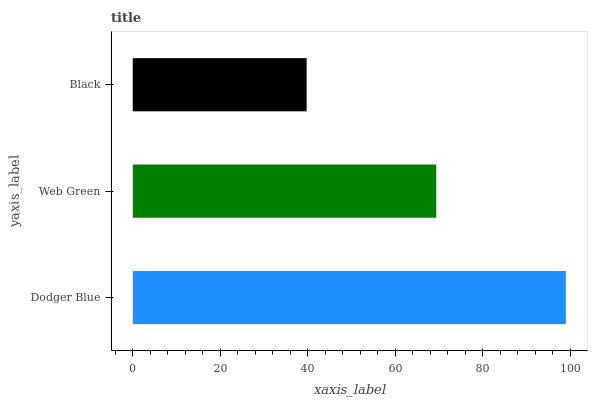Is Black the minimum?
Answer yes or no. Yes. Is Dodger Blue the maximum?
Answer yes or no. Yes. Is Web Green the minimum?
Answer yes or no. No. Is Web Green the maximum?
Answer yes or no. No. Is Dodger Blue greater than Web Green?
Answer yes or no. Yes. Is Web Green less than Dodger Blue?
Answer yes or no. Yes. Is Web Green greater than Dodger Blue?
Answer yes or no. No. Is Dodger Blue less than Web Green?
Answer yes or no. No. Is Web Green the high median?
Answer yes or no. Yes. Is Web Green the low median?
Answer yes or no. Yes. Is Black the high median?
Answer yes or no. No. Is Dodger Blue the low median?
Answer yes or no. No. 